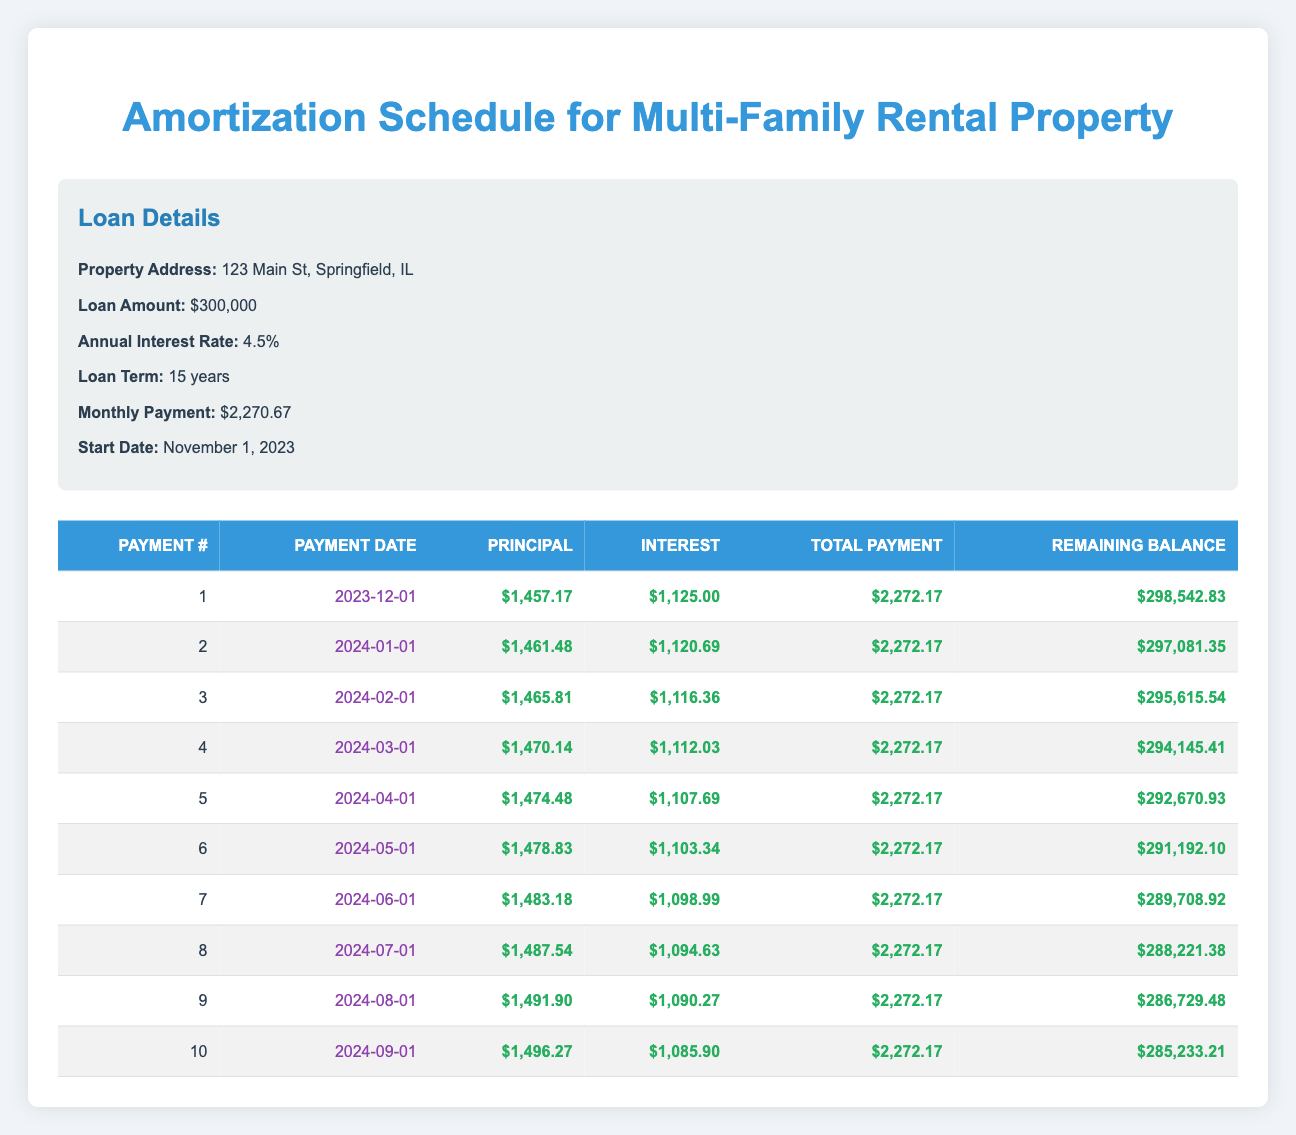What is the total payment of the first installment? In the table, the column labeled "Total Payment" for the first payment number shows $2,272.17.
Answer: $2,272.17 What is the principal payment for the second installment? The table indicates that the principal payment for the second installment, shown in the column "Principal," is $1,461.48.
Answer: $1,461.48 How much is the interest payment on the third installment? Referring to the table, the "Interest" column for the third payment number indicates the amount is $1,116.36.
Answer: $1,116.36 Is the interest payment for the fourth installment higher than the interest payment for the first installment? The interest payment for the fourth installment is $1,112.03 while it is $1,125.00 for the first installment. Since $1,112.03 is less than $1,125.00, the answer is no.
Answer: No What is the remaining balance after the sixth installment? The table shows that after the sixth payment, the column "Remaining Balance" indicates $291,192.10.
Answer: $291,192.10 What is the total amount paid towards principal after the first four payments? To find this, add the principal payments of the first four payments: $1,457.17 + $1,461.48 + $1,465.81 + $1,470.14 = $5,854.60.
Answer: $5,854.60 What is the average monthly payment across the first ten installments? Summing the total payments for the first ten installments equals $22,721.70 ($2,272.17 * 10). Dividing by 10 gives an average of $2,272.17.
Answer: $2,272.17 Is the principal paid in the seventh installment greater than the principal paid in the sixth installment? The principal payment for the seventh installment is $1,483.18, whereas for the sixth installment it is $1,478.83. Since $1,483.18 is greater than $1,478.83, the answer is yes.
Answer: Yes What is the total interest paid in the first five installments? Add up the interest payments from the first five rows: $1,125.00 + $1,120.69 + $1,116.36 + $1,112.03 + $1,107.69 = $5,581.77.
Answer: $5,581.77 